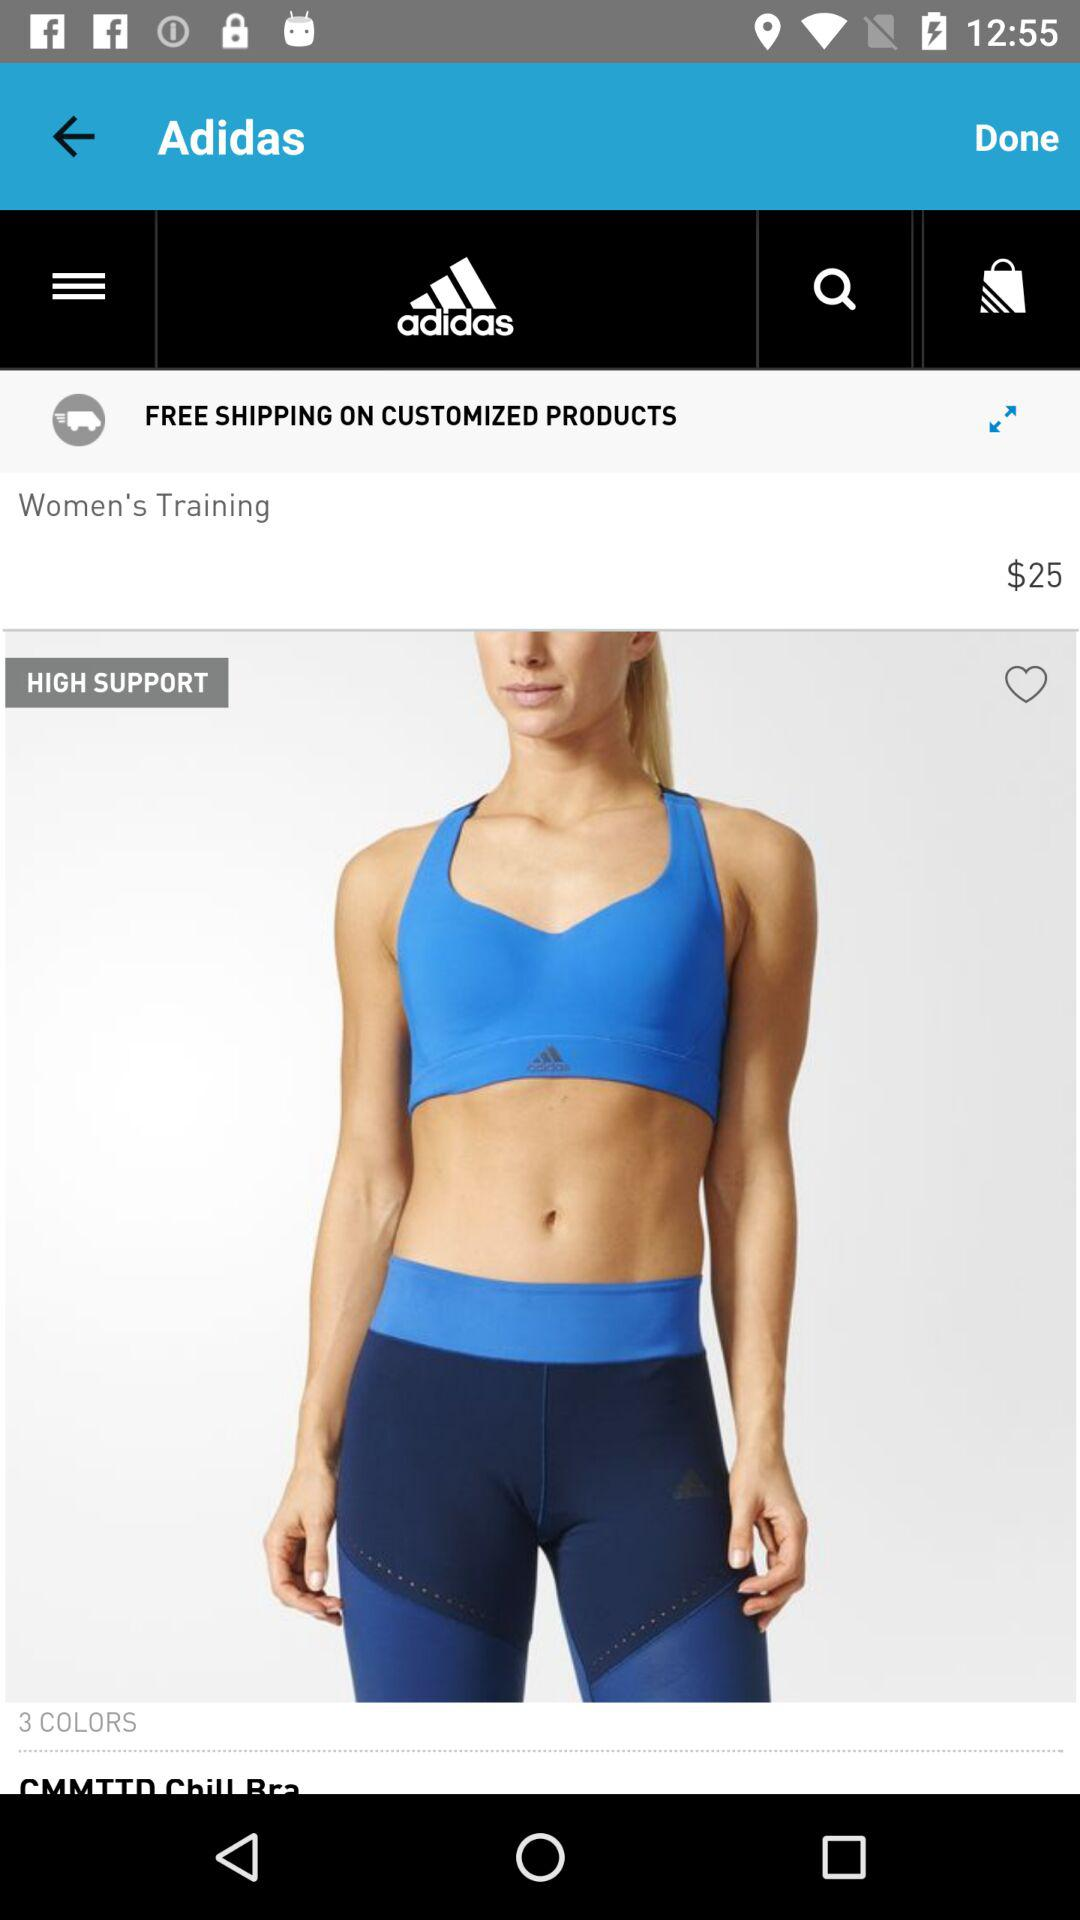What is the shipping price for customized products? The shipping price is free for customized products. 